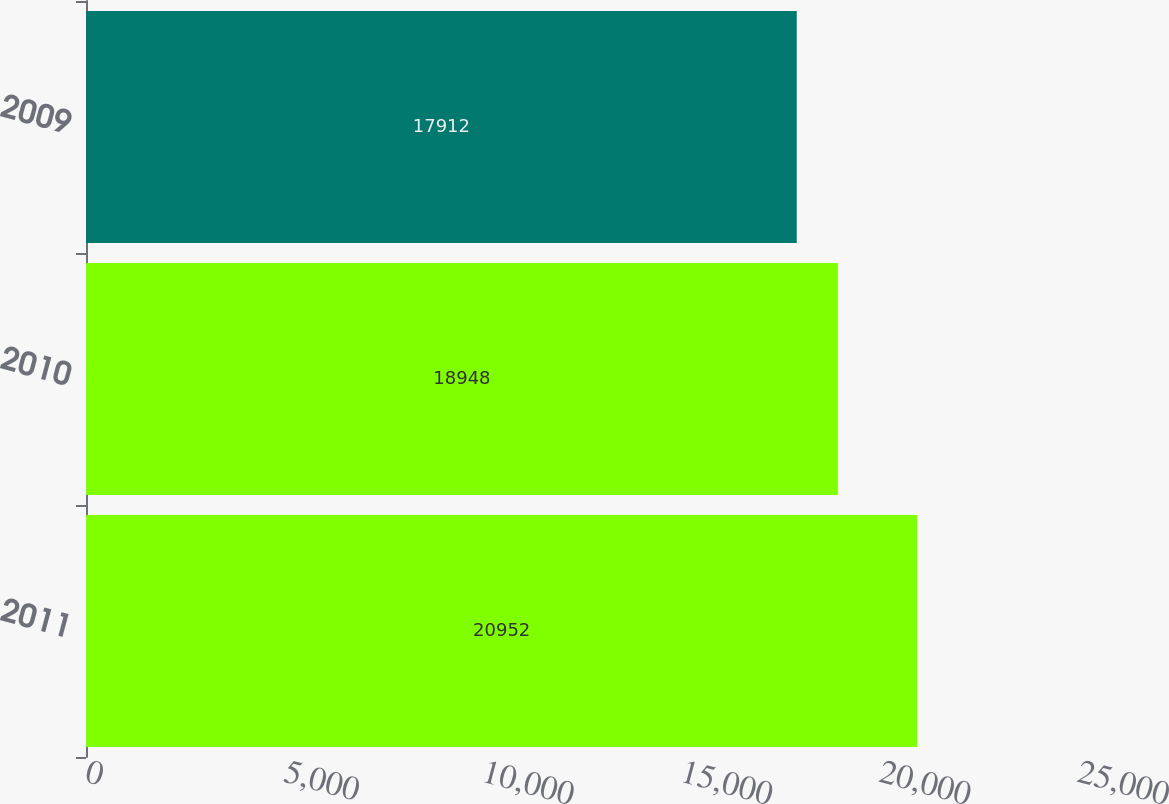Convert chart. <chart><loc_0><loc_0><loc_500><loc_500><bar_chart><fcel>2011<fcel>2010<fcel>2009<nl><fcel>20952<fcel>18948<fcel>17912<nl></chart> 